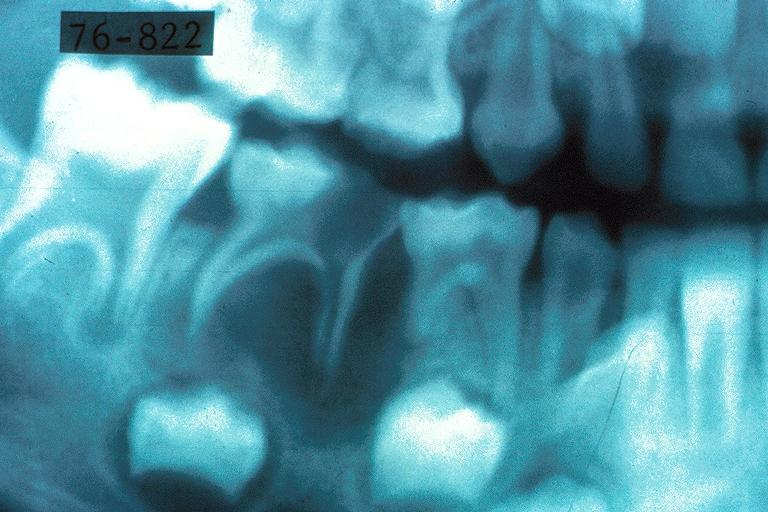where is this?
Answer the question using a single word or phrase. Oral 